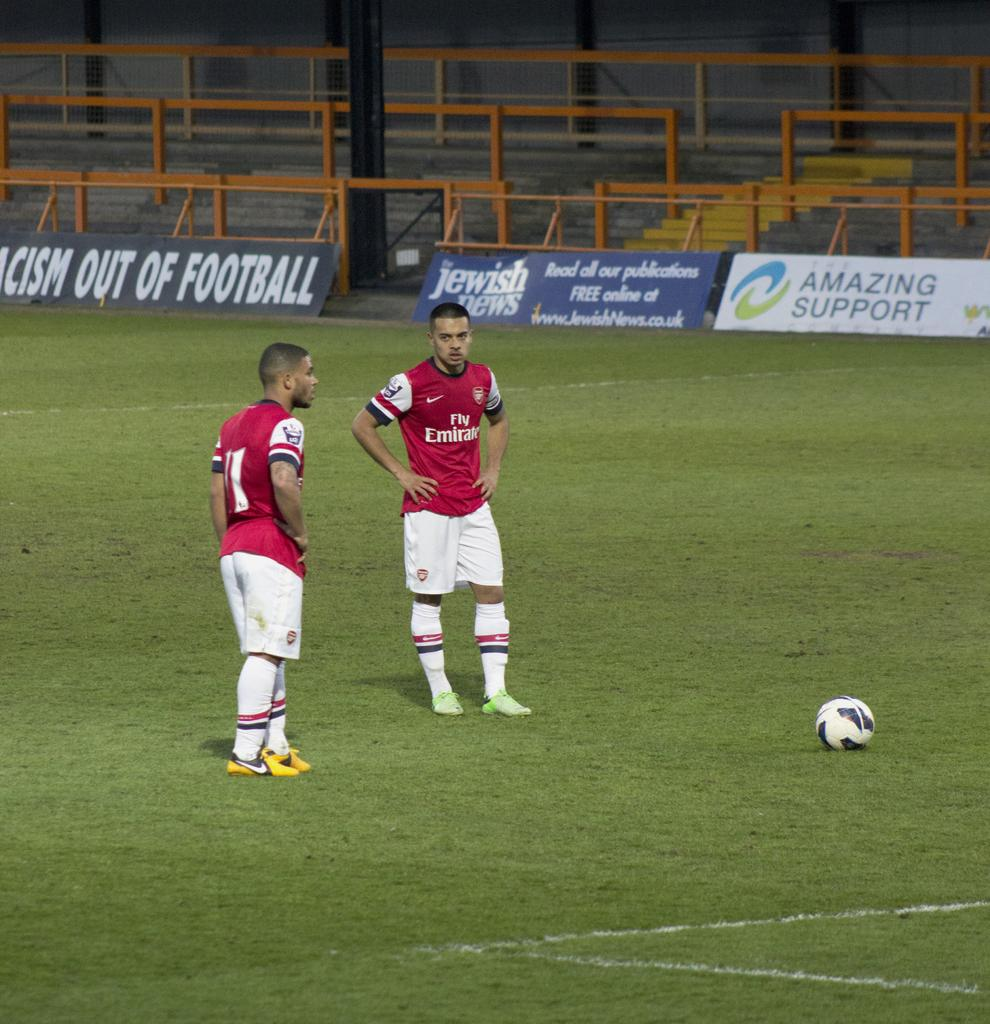Provide a one-sentence caption for the provided image. A placard on the edge of the soccer field i by the Jewish news. 